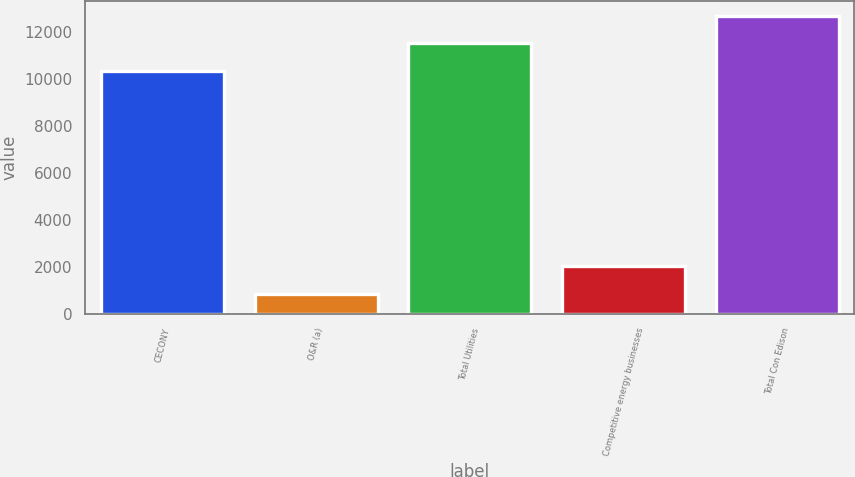Convert chart. <chart><loc_0><loc_0><loc_500><loc_500><bar_chart><fcel>CECONY<fcel>O&R (a)<fcel>Total Utilities<fcel>Competitive energy businesses<fcel>Total Con Edison<nl><fcel>10328<fcel>845<fcel>11498.9<fcel>2015.9<fcel>12669.8<nl></chart> 